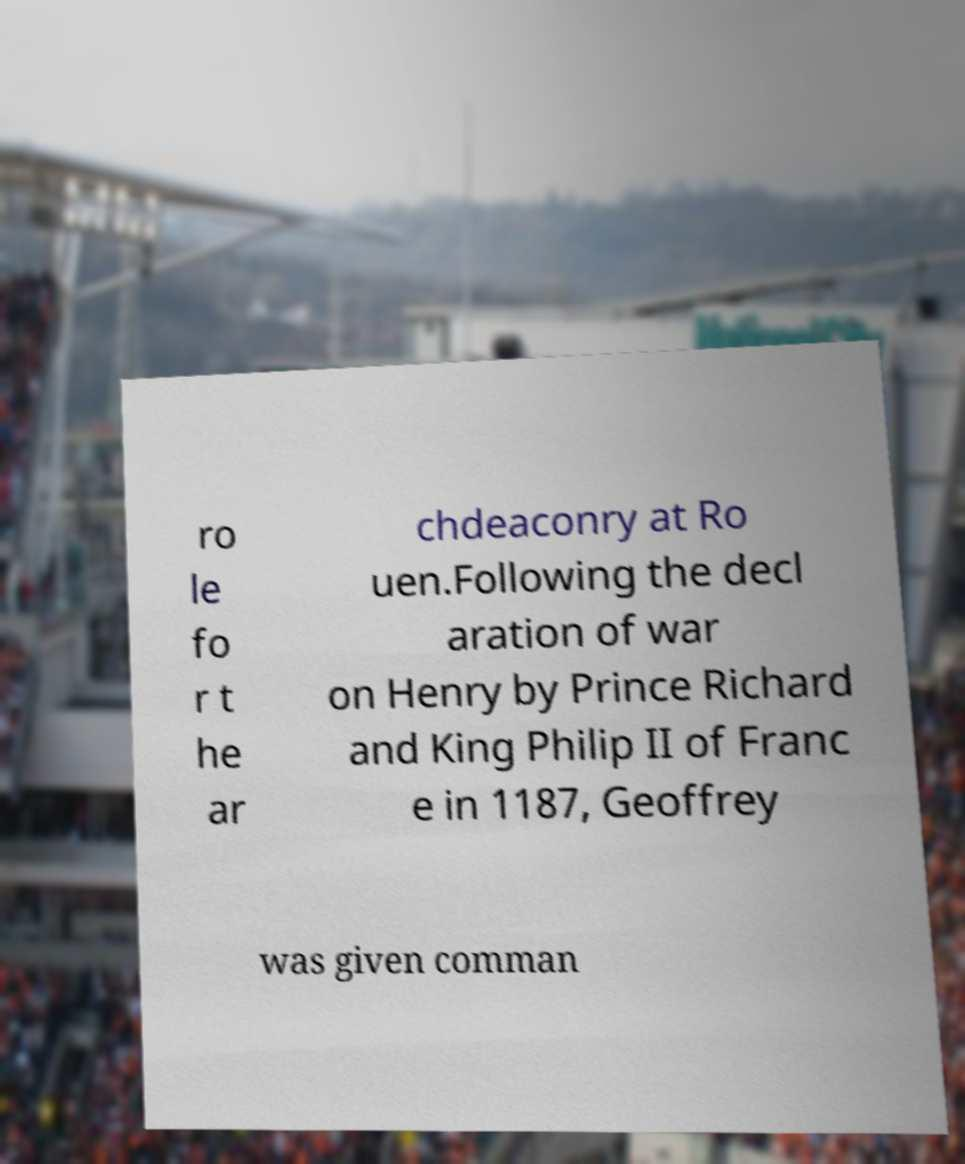For documentation purposes, I need the text within this image transcribed. Could you provide that? ro le fo r t he ar chdeaconry at Ro uen.Following the decl aration of war on Henry by Prince Richard and King Philip II of Franc e in 1187, Geoffrey was given comman 